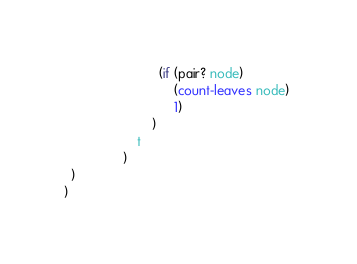<code> <loc_0><loc_0><loc_500><loc_500><_Scheme_>                          (if (pair? node) 
                              (count-leaves node) 
                              1)
                        )
                    t
                )
  )
)
</code> 